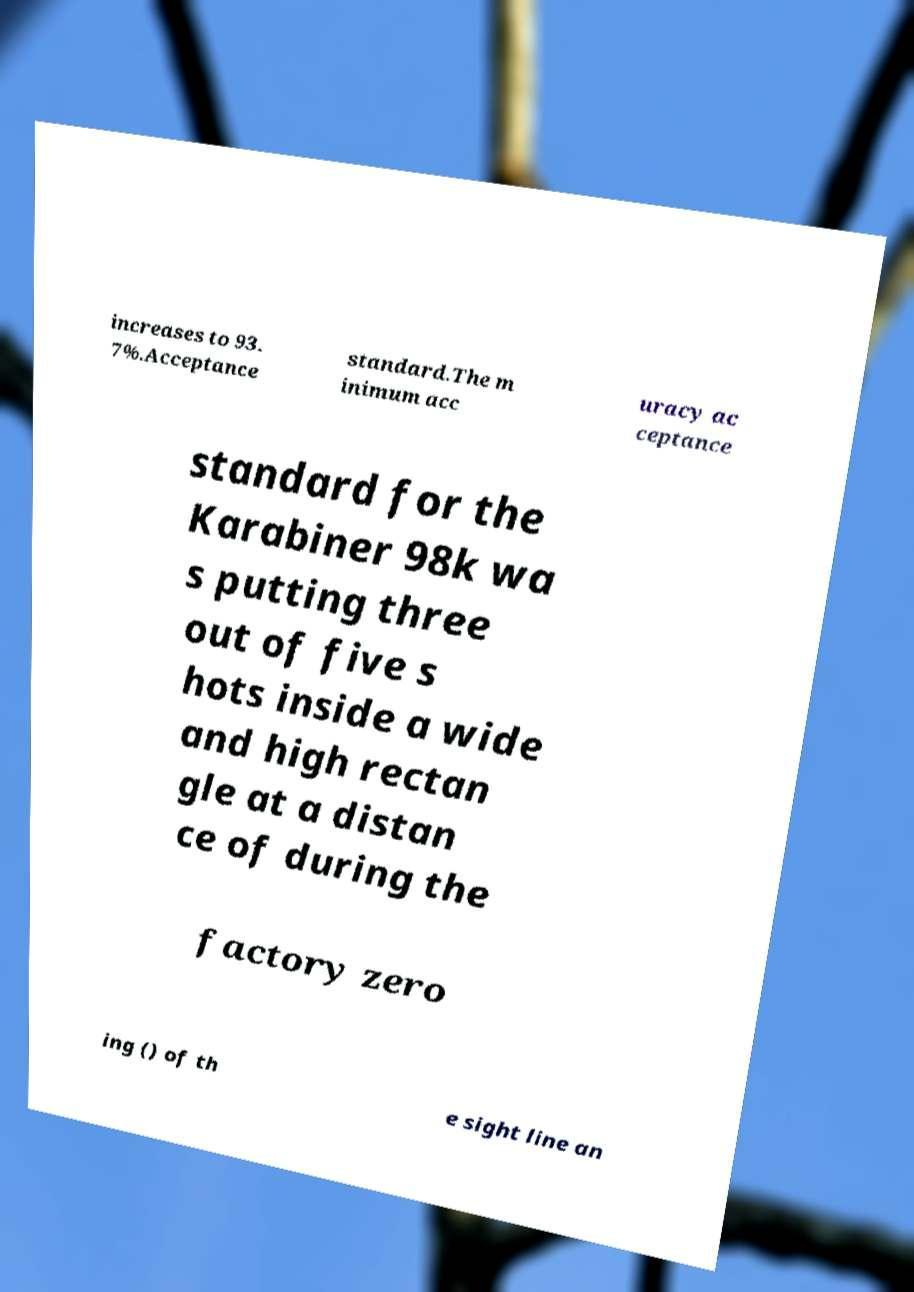Could you extract and type out the text from this image? increases to 93. 7%.Acceptance standard.The m inimum acc uracy ac ceptance standard for the Karabiner 98k wa s putting three out of five s hots inside a wide and high rectan gle at a distan ce of during the factory zero ing () of th e sight line an 